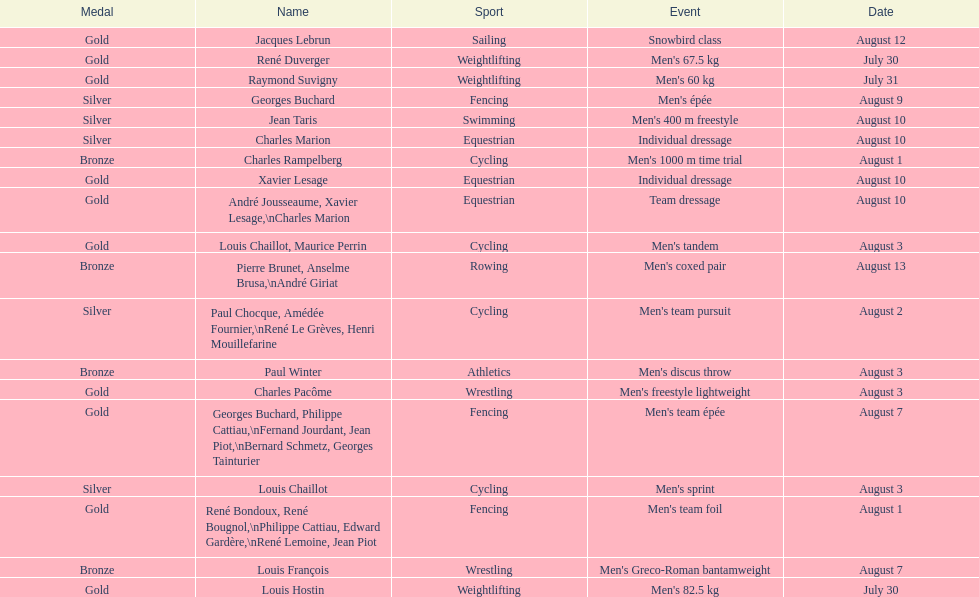What sport is listed first? Cycling. 